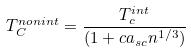<formula> <loc_0><loc_0><loc_500><loc_500>T _ { C } ^ { n o n i n t } = \frac { T ^ { i n t } _ { c } } { ( 1 + c a _ { s c } n ^ { 1 / 3 } ) }</formula> 